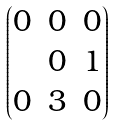Convert formula to latex. <formula><loc_0><loc_0><loc_500><loc_500>\begin{pmatrix} 0 & 0 & 0 \\ & 0 & 1 \\ 0 & 3 & 0 \end{pmatrix}</formula> 